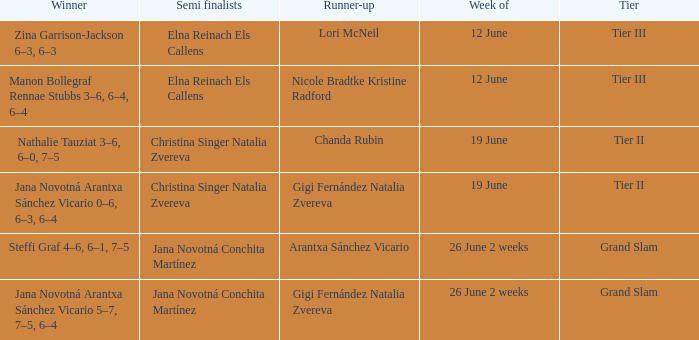In which week is the winner listed as Jana Novotná Arantxa Sánchez Vicario 5–7, 7–5, 6–4? 26 June 2 weeks. 